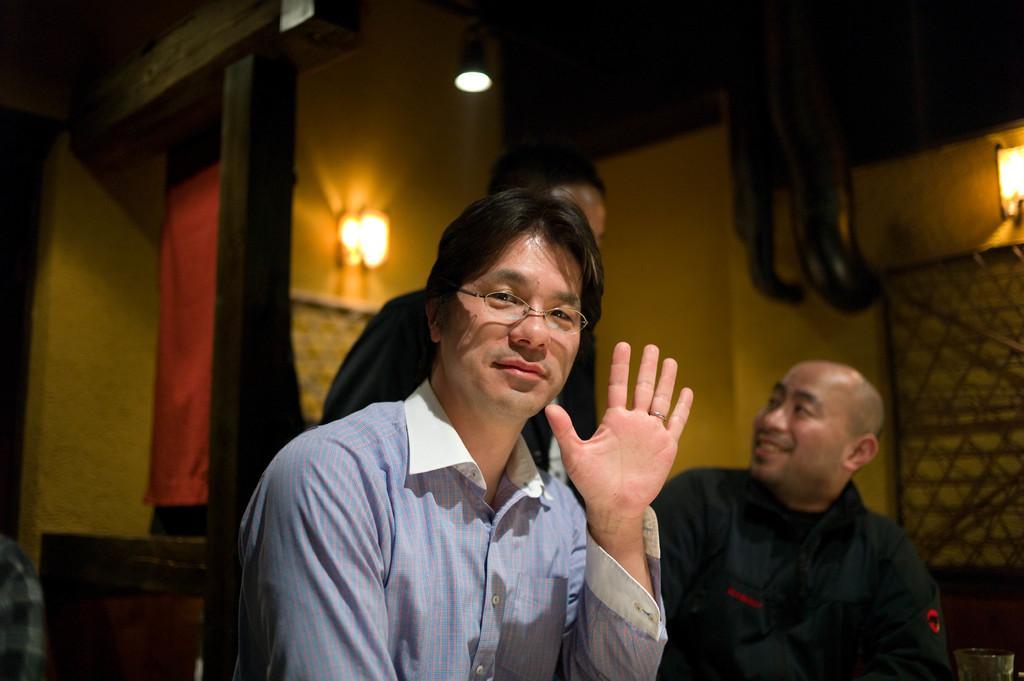In one or two sentences, can you explain what this image depicts? In this image 3 persons are there, one of the person is showing his hand and the other person is talking to another person. There is a lamp which is glowing. 